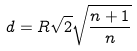Convert formula to latex. <formula><loc_0><loc_0><loc_500><loc_500>d = R \sqrt { 2 } \sqrt { \frac { n + 1 } { n } }</formula> 